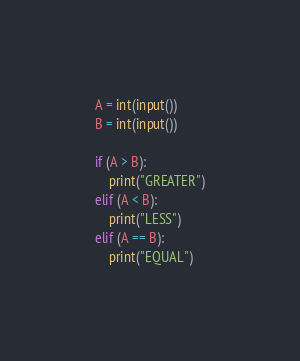<code> <loc_0><loc_0><loc_500><loc_500><_Python_>
A = int(input())
B = int(input())

if (A > B):
    print("GREATER")
elif (A < B):
    print("LESS")
elif (A == B):
    print("EQUAL")</code> 